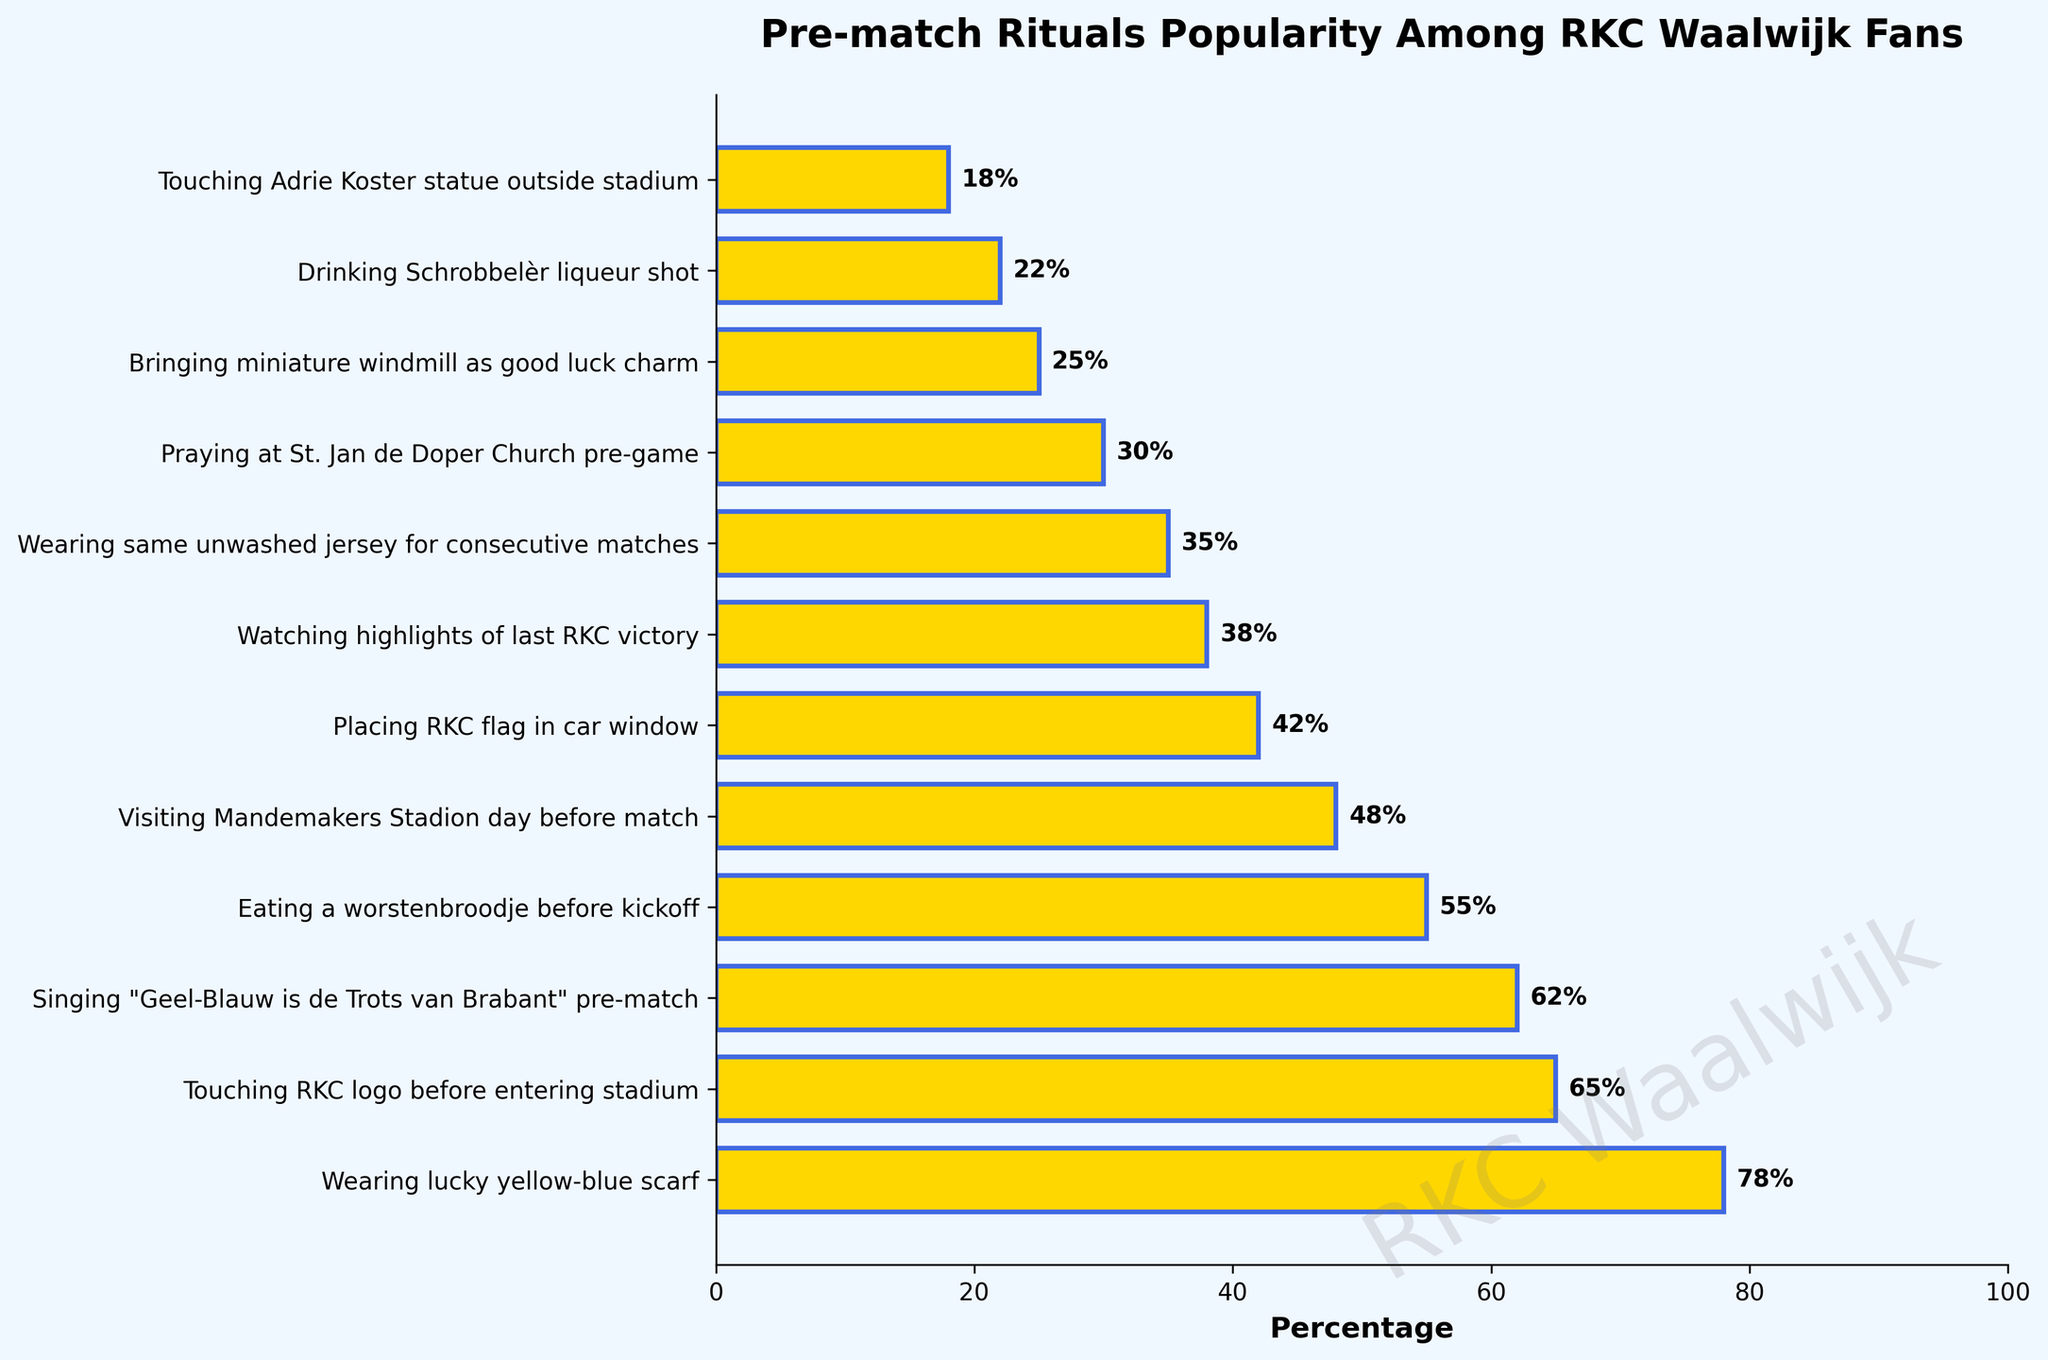Which pre-match ritual is the most popular among RKC Waalwijk fans? By observing the horizontal bar chart, the longest bar represents the most popular pre-match ritual. The longest bar corresponds to "Wearing lucky yellow-blue scarf" with a percentage value of 78%.
Answer: Wearing lucky yellow-blue scarf What is the difference in popularity between the most and least popular rituals? Identify the most popular ritual "Wearing lucky yellow-blue scarf" (78%) and the least popular ritual "Touching Adrie Koster statue outside stadium" (18%). Subtract the percentage of the least popular ritual from the most popular ritual: 78% - 18% = 60%.
Answer: 60% Which ritual has a higher percentage, "Eating a worstenbroodje before kickoff" or "Visiting Mandemakers Stadion day before match"? Compare the bar lengths of "Eating a worstenbroodje before kickoff" (55%) and "Visiting Mandemakers Stadion day before match" (48%). The larger value indicates the higher percentage.
Answer: Eating a worstenbroodje before kickoff What is the combined percentage of the top three most popular rituals? Identify the top three most popular rituals: "Wearing lucky yellow-blue scarf" (78%), "Touching RKC logo before entering stadium" (65%), and "Singing 'Geel-Blauw is de Trots van Brabant' pre-match" (62%). Compute the sum: 78% + 65% + 62% = 205%.
Answer: 205% Which rituals have a popularity percentage greater than 50%? Look at the percentages associated with each bar. Identify those with more than 50%: "Wearing lucky yellow-blue scarf" (78%), "Touching RKC logo before entering stadium" (65%), "Singing 'Geel-Blauw is de Trots van Brabant' pre-match" (62%), and "Eating a worstenbroodje before kickoff" (55%).
Answer: Wearing lucky yellow-blue scarf; Touching RKC logo before entering stadium; Singing 'Geel-Blauw is de Trots van Brabant' pre-match; Eating a worstenbroodje before kickoff Is the percentage of fans who wear the same unwashed jersey for consecutive matches higher or lower than those who watch highlights of the last RKC victory? Look at the bars for "Wearing same unwashed jersey for consecutive matches" (35%) and "Watching highlights of last RKC victory" (38%). Compare the lengths to determine which is higher.
Answer: Lower What is the average popularity percentage of the rituals "Placing RKC flag in car window" and "Drinking Schrobbelèr liqueur shot"? Add the percentages for "Placing RKC flag in car window" (42%) and "Drinking Schrobbelèr liqueur shot" (22%), then divide by 2 to find the average: (42% + 22%) / 2 = 32%.
Answer: 32% How much more popular is praying at St. Jan de Doper Church pre-game than bringing a miniature windmill as a good luck charm? Compare the bars for "Praying at St. Jan de Doper Church pre-game" (30%) and "Bringing miniature windmill as good luck charm" (25%). Subtract the lesser percentage from the greater one: 30% - 25% = 5%.
Answer: 5% What is the total percentage of fans who engage in the three least popular rituals? Identify the three least popular rituals: "Drinking Schrobbelèr liqueur shot" (22%), "Touching Adrie Koster statue outside stadium" (18%), and "Bringing miniature windmill as good luck charm" (25%). Compute the sum: 22% + 18% + 25% = 65%.
Answer: 65% 